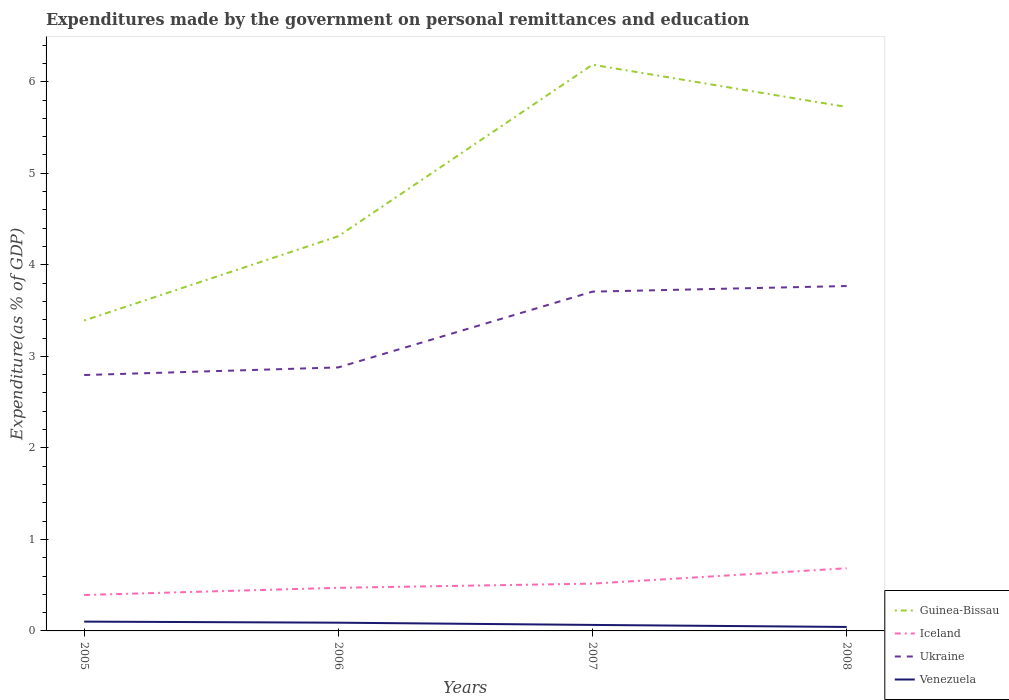How many different coloured lines are there?
Your answer should be very brief. 4. Does the line corresponding to Guinea-Bissau intersect with the line corresponding to Ukraine?
Offer a terse response. No. Across all years, what is the maximum expenditures made by the government on personal remittances and education in Guinea-Bissau?
Offer a terse response. 3.39. In which year was the expenditures made by the government on personal remittances and education in Iceland maximum?
Your response must be concise. 2005. What is the total expenditures made by the government on personal remittances and education in Ukraine in the graph?
Provide a succinct answer. -0.83. What is the difference between the highest and the second highest expenditures made by the government on personal remittances and education in Ukraine?
Your answer should be compact. 0.97. What is the difference between the highest and the lowest expenditures made by the government on personal remittances and education in Guinea-Bissau?
Give a very brief answer. 2. Is the expenditures made by the government on personal remittances and education in Iceland strictly greater than the expenditures made by the government on personal remittances and education in Ukraine over the years?
Your answer should be very brief. Yes. Does the graph contain grids?
Give a very brief answer. No. Where does the legend appear in the graph?
Offer a very short reply. Bottom right. How are the legend labels stacked?
Give a very brief answer. Vertical. What is the title of the graph?
Provide a short and direct response. Expenditures made by the government on personal remittances and education. Does "Channel Islands" appear as one of the legend labels in the graph?
Make the answer very short. No. What is the label or title of the Y-axis?
Keep it short and to the point. Expenditure(as % of GDP). What is the Expenditure(as % of GDP) in Guinea-Bissau in 2005?
Provide a short and direct response. 3.39. What is the Expenditure(as % of GDP) in Iceland in 2005?
Ensure brevity in your answer.  0.39. What is the Expenditure(as % of GDP) of Ukraine in 2005?
Give a very brief answer. 2.8. What is the Expenditure(as % of GDP) in Venezuela in 2005?
Offer a terse response. 0.1. What is the Expenditure(as % of GDP) in Guinea-Bissau in 2006?
Provide a succinct answer. 4.31. What is the Expenditure(as % of GDP) in Iceland in 2006?
Your response must be concise. 0.47. What is the Expenditure(as % of GDP) in Ukraine in 2006?
Make the answer very short. 2.88. What is the Expenditure(as % of GDP) of Venezuela in 2006?
Offer a very short reply. 0.09. What is the Expenditure(as % of GDP) of Guinea-Bissau in 2007?
Give a very brief answer. 6.19. What is the Expenditure(as % of GDP) of Iceland in 2007?
Offer a terse response. 0.52. What is the Expenditure(as % of GDP) of Ukraine in 2007?
Provide a succinct answer. 3.71. What is the Expenditure(as % of GDP) in Venezuela in 2007?
Offer a very short reply. 0.07. What is the Expenditure(as % of GDP) of Guinea-Bissau in 2008?
Offer a very short reply. 5.72. What is the Expenditure(as % of GDP) in Iceland in 2008?
Give a very brief answer. 0.68. What is the Expenditure(as % of GDP) in Ukraine in 2008?
Your response must be concise. 3.77. What is the Expenditure(as % of GDP) of Venezuela in 2008?
Offer a very short reply. 0.04. Across all years, what is the maximum Expenditure(as % of GDP) in Guinea-Bissau?
Your answer should be compact. 6.19. Across all years, what is the maximum Expenditure(as % of GDP) of Iceland?
Offer a very short reply. 0.68. Across all years, what is the maximum Expenditure(as % of GDP) of Ukraine?
Offer a terse response. 3.77. Across all years, what is the maximum Expenditure(as % of GDP) in Venezuela?
Your response must be concise. 0.1. Across all years, what is the minimum Expenditure(as % of GDP) of Guinea-Bissau?
Your answer should be compact. 3.39. Across all years, what is the minimum Expenditure(as % of GDP) in Iceland?
Ensure brevity in your answer.  0.39. Across all years, what is the minimum Expenditure(as % of GDP) in Ukraine?
Your answer should be compact. 2.8. Across all years, what is the minimum Expenditure(as % of GDP) of Venezuela?
Your answer should be very brief. 0.04. What is the total Expenditure(as % of GDP) in Guinea-Bissau in the graph?
Offer a very short reply. 19.61. What is the total Expenditure(as % of GDP) in Iceland in the graph?
Give a very brief answer. 2.06. What is the total Expenditure(as % of GDP) in Ukraine in the graph?
Your response must be concise. 13.15. What is the total Expenditure(as % of GDP) in Venezuela in the graph?
Make the answer very short. 0.3. What is the difference between the Expenditure(as % of GDP) in Guinea-Bissau in 2005 and that in 2006?
Your response must be concise. -0.92. What is the difference between the Expenditure(as % of GDP) in Iceland in 2005 and that in 2006?
Keep it short and to the point. -0.08. What is the difference between the Expenditure(as % of GDP) of Ukraine in 2005 and that in 2006?
Your answer should be compact. -0.08. What is the difference between the Expenditure(as % of GDP) in Venezuela in 2005 and that in 2006?
Your response must be concise. 0.01. What is the difference between the Expenditure(as % of GDP) of Guinea-Bissau in 2005 and that in 2007?
Make the answer very short. -2.79. What is the difference between the Expenditure(as % of GDP) in Iceland in 2005 and that in 2007?
Keep it short and to the point. -0.12. What is the difference between the Expenditure(as % of GDP) of Ukraine in 2005 and that in 2007?
Give a very brief answer. -0.91. What is the difference between the Expenditure(as % of GDP) in Venezuela in 2005 and that in 2007?
Ensure brevity in your answer.  0.04. What is the difference between the Expenditure(as % of GDP) in Guinea-Bissau in 2005 and that in 2008?
Make the answer very short. -2.33. What is the difference between the Expenditure(as % of GDP) in Iceland in 2005 and that in 2008?
Make the answer very short. -0.29. What is the difference between the Expenditure(as % of GDP) of Ukraine in 2005 and that in 2008?
Keep it short and to the point. -0.97. What is the difference between the Expenditure(as % of GDP) of Venezuela in 2005 and that in 2008?
Offer a terse response. 0.06. What is the difference between the Expenditure(as % of GDP) in Guinea-Bissau in 2006 and that in 2007?
Provide a short and direct response. -1.87. What is the difference between the Expenditure(as % of GDP) in Iceland in 2006 and that in 2007?
Ensure brevity in your answer.  -0.05. What is the difference between the Expenditure(as % of GDP) in Ukraine in 2006 and that in 2007?
Ensure brevity in your answer.  -0.83. What is the difference between the Expenditure(as % of GDP) of Venezuela in 2006 and that in 2007?
Offer a very short reply. 0.02. What is the difference between the Expenditure(as % of GDP) in Guinea-Bissau in 2006 and that in 2008?
Provide a succinct answer. -1.41. What is the difference between the Expenditure(as % of GDP) of Iceland in 2006 and that in 2008?
Ensure brevity in your answer.  -0.21. What is the difference between the Expenditure(as % of GDP) of Ukraine in 2006 and that in 2008?
Your response must be concise. -0.89. What is the difference between the Expenditure(as % of GDP) in Venezuela in 2006 and that in 2008?
Provide a succinct answer. 0.05. What is the difference between the Expenditure(as % of GDP) of Guinea-Bissau in 2007 and that in 2008?
Your answer should be very brief. 0.46. What is the difference between the Expenditure(as % of GDP) in Iceland in 2007 and that in 2008?
Offer a terse response. -0.17. What is the difference between the Expenditure(as % of GDP) of Ukraine in 2007 and that in 2008?
Keep it short and to the point. -0.06. What is the difference between the Expenditure(as % of GDP) of Venezuela in 2007 and that in 2008?
Your answer should be very brief. 0.02. What is the difference between the Expenditure(as % of GDP) in Guinea-Bissau in 2005 and the Expenditure(as % of GDP) in Iceland in 2006?
Make the answer very short. 2.92. What is the difference between the Expenditure(as % of GDP) in Guinea-Bissau in 2005 and the Expenditure(as % of GDP) in Ukraine in 2006?
Provide a succinct answer. 0.51. What is the difference between the Expenditure(as % of GDP) of Guinea-Bissau in 2005 and the Expenditure(as % of GDP) of Venezuela in 2006?
Keep it short and to the point. 3.3. What is the difference between the Expenditure(as % of GDP) of Iceland in 2005 and the Expenditure(as % of GDP) of Ukraine in 2006?
Make the answer very short. -2.49. What is the difference between the Expenditure(as % of GDP) of Iceland in 2005 and the Expenditure(as % of GDP) of Venezuela in 2006?
Make the answer very short. 0.3. What is the difference between the Expenditure(as % of GDP) in Ukraine in 2005 and the Expenditure(as % of GDP) in Venezuela in 2006?
Offer a very short reply. 2.71. What is the difference between the Expenditure(as % of GDP) in Guinea-Bissau in 2005 and the Expenditure(as % of GDP) in Iceland in 2007?
Provide a short and direct response. 2.87. What is the difference between the Expenditure(as % of GDP) of Guinea-Bissau in 2005 and the Expenditure(as % of GDP) of Ukraine in 2007?
Provide a succinct answer. -0.32. What is the difference between the Expenditure(as % of GDP) in Guinea-Bissau in 2005 and the Expenditure(as % of GDP) in Venezuela in 2007?
Provide a short and direct response. 3.33. What is the difference between the Expenditure(as % of GDP) of Iceland in 2005 and the Expenditure(as % of GDP) of Ukraine in 2007?
Your response must be concise. -3.31. What is the difference between the Expenditure(as % of GDP) of Iceland in 2005 and the Expenditure(as % of GDP) of Venezuela in 2007?
Your answer should be very brief. 0.33. What is the difference between the Expenditure(as % of GDP) in Ukraine in 2005 and the Expenditure(as % of GDP) in Venezuela in 2007?
Make the answer very short. 2.73. What is the difference between the Expenditure(as % of GDP) of Guinea-Bissau in 2005 and the Expenditure(as % of GDP) of Iceland in 2008?
Your answer should be very brief. 2.71. What is the difference between the Expenditure(as % of GDP) in Guinea-Bissau in 2005 and the Expenditure(as % of GDP) in Ukraine in 2008?
Offer a very short reply. -0.38. What is the difference between the Expenditure(as % of GDP) of Guinea-Bissau in 2005 and the Expenditure(as % of GDP) of Venezuela in 2008?
Provide a short and direct response. 3.35. What is the difference between the Expenditure(as % of GDP) of Iceland in 2005 and the Expenditure(as % of GDP) of Ukraine in 2008?
Your answer should be compact. -3.38. What is the difference between the Expenditure(as % of GDP) of Iceland in 2005 and the Expenditure(as % of GDP) of Venezuela in 2008?
Provide a succinct answer. 0.35. What is the difference between the Expenditure(as % of GDP) in Ukraine in 2005 and the Expenditure(as % of GDP) in Venezuela in 2008?
Give a very brief answer. 2.75. What is the difference between the Expenditure(as % of GDP) of Guinea-Bissau in 2006 and the Expenditure(as % of GDP) of Iceland in 2007?
Your answer should be very brief. 3.8. What is the difference between the Expenditure(as % of GDP) in Guinea-Bissau in 2006 and the Expenditure(as % of GDP) in Ukraine in 2007?
Provide a short and direct response. 0.61. What is the difference between the Expenditure(as % of GDP) of Guinea-Bissau in 2006 and the Expenditure(as % of GDP) of Venezuela in 2007?
Give a very brief answer. 4.25. What is the difference between the Expenditure(as % of GDP) in Iceland in 2006 and the Expenditure(as % of GDP) in Ukraine in 2007?
Make the answer very short. -3.24. What is the difference between the Expenditure(as % of GDP) of Iceland in 2006 and the Expenditure(as % of GDP) of Venezuela in 2007?
Provide a succinct answer. 0.41. What is the difference between the Expenditure(as % of GDP) of Ukraine in 2006 and the Expenditure(as % of GDP) of Venezuela in 2007?
Provide a short and direct response. 2.81. What is the difference between the Expenditure(as % of GDP) of Guinea-Bissau in 2006 and the Expenditure(as % of GDP) of Iceland in 2008?
Provide a succinct answer. 3.63. What is the difference between the Expenditure(as % of GDP) in Guinea-Bissau in 2006 and the Expenditure(as % of GDP) in Ukraine in 2008?
Keep it short and to the point. 0.54. What is the difference between the Expenditure(as % of GDP) in Guinea-Bissau in 2006 and the Expenditure(as % of GDP) in Venezuela in 2008?
Offer a terse response. 4.27. What is the difference between the Expenditure(as % of GDP) in Iceland in 2006 and the Expenditure(as % of GDP) in Ukraine in 2008?
Offer a very short reply. -3.3. What is the difference between the Expenditure(as % of GDP) in Iceland in 2006 and the Expenditure(as % of GDP) in Venezuela in 2008?
Offer a terse response. 0.43. What is the difference between the Expenditure(as % of GDP) of Ukraine in 2006 and the Expenditure(as % of GDP) of Venezuela in 2008?
Make the answer very short. 2.84. What is the difference between the Expenditure(as % of GDP) in Guinea-Bissau in 2007 and the Expenditure(as % of GDP) in Iceland in 2008?
Offer a terse response. 5.5. What is the difference between the Expenditure(as % of GDP) of Guinea-Bissau in 2007 and the Expenditure(as % of GDP) of Ukraine in 2008?
Offer a very short reply. 2.42. What is the difference between the Expenditure(as % of GDP) in Guinea-Bissau in 2007 and the Expenditure(as % of GDP) in Venezuela in 2008?
Provide a short and direct response. 6.14. What is the difference between the Expenditure(as % of GDP) in Iceland in 2007 and the Expenditure(as % of GDP) in Ukraine in 2008?
Offer a very short reply. -3.25. What is the difference between the Expenditure(as % of GDP) of Iceland in 2007 and the Expenditure(as % of GDP) of Venezuela in 2008?
Offer a very short reply. 0.47. What is the difference between the Expenditure(as % of GDP) in Ukraine in 2007 and the Expenditure(as % of GDP) in Venezuela in 2008?
Make the answer very short. 3.66. What is the average Expenditure(as % of GDP) of Guinea-Bissau per year?
Keep it short and to the point. 4.9. What is the average Expenditure(as % of GDP) in Iceland per year?
Offer a very short reply. 0.52. What is the average Expenditure(as % of GDP) in Ukraine per year?
Ensure brevity in your answer.  3.29. What is the average Expenditure(as % of GDP) in Venezuela per year?
Provide a short and direct response. 0.08. In the year 2005, what is the difference between the Expenditure(as % of GDP) in Guinea-Bissau and Expenditure(as % of GDP) in Iceland?
Your answer should be compact. 3. In the year 2005, what is the difference between the Expenditure(as % of GDP) of Guinea-Bissau and Expenditure(as % of GDP) of Ukraine?
Your response must be concise. 0.6. In the year 2005, what is the difference between the Expenditure(as % of GDP) of Guinea-Bissau and Expenditure(as % of GDP) of Venezuela?
Provide a succinct answer. 3.29. In the year 2005, what is the difference between the Expenditure(as % of GDP) of Iceland and Expenditure(as % of GDP) of Ukraine?
Provide a short and direct response. -2.4. In the year 2005, what is the difference between the Expenditure(as % of GDP) in Iceland and Expenditure(as % of GDP) in Venezuela?
Keep it short and to the point. 0.29. In the year 2005, what is the difference between the Expenditure(as % of GDP) of Ukraine and Expenditure(as % of GDP) of Venezuela?
Offer a terse response. 2.69. In the year 2006, what is the difference between the Expenditure(as % of GDP) of Guinea-Bissau and Expenditure(as % of GDP) of Iceland?
Ensure brevity in your answer.  3.84. In the year 2006, what is the difference between the Expenditure(as % of GDP) of Guinea-Bissau and Expenditure(as % of GDP) of Ukraine?
Give a very brief answer. 1.43. In the year 2006, what is the difference between the Expenditure(as % of GDP) in Guinea-Bissau and Expenditure(as % of GDP) in Venezuela?
Your answer should be compact. 4.22. In the year 2006, what is the difference between the Expenditure(as % of GDP) in Iceland and Expenditure(as % of GDP) in Ukraine?
Give a very brief answer. -2.41. In the year 2006, what is the difference between the Expenditure(as % of GDP) of Iceland and Expenditure(as % of GDP) of Venezuela?
Give a very brief answer. 0.38. In the year 2006, what is the difference between the Expenditure(as % of GDP) of Ukraine and Expenditure(as % of GDP) of Venezuela?
Your response must be concise. 2.79. In the year 2007, what is the difference between the Expenditure(as % of GDP) of Guinea-Bissau and Expenditure(as % of GDP) of Iceland?
Give a very brief answer. 5.67. In the year 2007, what is the difference between the Expenditure(as % of GDP) of Guinea-Bissau and Expenditure(as % of GDP) of Ukraine?
Offer a very short reply. 2.48. In the year 2007, what is the difference between the Expenditure(as % of GDP) of Guinea-Bissau and Expenditure(as % of GDP) of Venezuela?
Your answer should be very brief. 6.12. In the year 2007, what is the difference between the Expenditure(as % of GDP) in Iceland and Expenditure(as % of GDP) in Ukraine?
Keep it short and to the point. -3.19. In the year 2007, what is the difference between the Expenditure(as % of GDP) of Iceland and Expenditure(as % of GDP) of Venezuela?
Provide a short and direct response. 0.45. In the year 2007, what is the difference between the Expenditure(as % of GDP) in Ukraine and Expenditure(as % of GDP) in Venezuela?
Offer a very short reply. 3.64. In the year 2008, what is the difference between the Expenditure(as % of GDP) of Guinea-Bissau and Expenditure(as % of GDP) of Iceland?
Keep it short and to the point. 5.04. In the year 2008, what is the difference between the Expenditure(as % of GDP) of Guinea-Bissau and Expenditure(as % of GDP) of Ukraine?
Provide a short and direct response. 1.96. In the year 2008, what is the difference between the Expenditure(as % of GDP) of Guinea-Bissau and Expenditure(as % of GDP) of Venezuela?
Ensure brevity in your answer.  5.68. In the year 2008, what is the difference between the Expenditure(as % of GDP) of Iceland and Expenditure(as % of GDP) of Ukraine?
Offer a very short reply. -3.08. In the year 2008, what is the difference between the Expenditure(as % of GDP) of Iceland and Expenditure(as % of GDP) of Venezuela?
Offer a terse response. 0.64. In the year 2008, what is the difference between the Expenditure(as % of GDP) in Ukraine and Expenditure(as % of GDP) in Venezuela?
Your answer should be compact. 3.72. What is the ratio of the Expenditure(as % of GDP) of Guinea-Bissau in 2005 to that in 2006?
Provide a succinct answer. 0.79. What is the ratio of the Expenditure(as % of GDP) of Iceland in 2005 to that in 2006?
Make the answer very short. 0.83. What is the ratio of the Expenditure(as % of GDP) of Ukraine in 2005 to that in 2006?
Offer a terse response. 0.97. What is the ratio of the Expenditure(as % of GDP) of Venezuela in 2005 to that in 2006?
Provide a short and direct response. 1.13. What is the ratio of the Expenditure(as % of GDP) of Guinea-Bissau in 2005 to that in 2007?
Offer a very short reply. 0.55. What is the ratio of the Expenditure(as % of GDP) of Iceland in 2005 to that in 2007?
Your response must be concise. 0.76. What is the ratio of the Expenditure(as % of GDP) in Ukraine in 2005 to that in 2007?
Ensure brevity in your answer.  0.75. What is the ratio of the Expenditure(as % of GDP) of Venezuela in 2005 to that in 2007?
Your answer should be very brief. 1.55. What is the ratio of the Expenditure(as % of GDP) of Guinea-Bissau in 2005 to that in 2008?
Provide a short and direct response. 0.59. What is the ratio of the Expenditure(as % of GDP) of Iceland in 2005 to that in 2008?
Provide a succinct answer. 0.57. What is the ratio of the Expenditure(as % of GDP) in Ukraine in 2005 to that in 2008?
Make the answer very short. 0.74. What is the ratio of the Expenditure(as % of GDP) in Venezuela in 2005 to that in 2008?
Your response must be concise. 2.34. What is the ratio of the Expenditure(as % of GDP) of Guinea-Bissau in 2006 to that in 2007?
Offer a terse response. 0.7. What is the ratio of the Expenditure(as % of GDP) in Iceland in 2006 to that in 2007?
Provide a succinct answer. 0.91. What is the ratio of the Expenditure(as % of GDP) of Ukraine in 2006 to that in 2007?
Your response must be concise. 0.78. What is the ratio of the Expenditure(as % of GDP) of Venezuela in 2006 to that in 2007?
Offer a terse response. 1.37. What is the ratio of the Expenditure(as % of GDP) of Guinea-Bissau in 2006 to that in 2008?
Your response must be concise. 0.75. What is the ratio of the Expenditure(as % of GDP) in Iceland in 2006 to that in 2008?
Your answer should be compact. 0.69. What is the ratio of the Expenditure(as % of GDP) in Ukraine in 2006 to that in 2008?
Provide a succinct answer. 0.76. What is the ratio of the Expenditure(as % of GDP) of Venezuela in 2006 to that in 2008?
Your response must be concise. 2.07. What is the ratio of the Expenditure(as % of GDP) of Guinea-Bissau in 2007 to that in 2008?
Make the answer very short. 1.08. What is the ratio of the Expenditure(as % of GDP) in Iceland in 2007 to that in 2008?
Make the answer very short. 0.75. What is the ratio of the Expenditure(as % of GDP) of Ukraine in 2007 to that in 2008?
Ensure brevity in your answer.  0.98. What is the ratio of the Expenditure(as % of GDP) of Venezuela in 2007 to that in 2008?
Your answer should be compact. 1.51. What is the difference between the highest and the second highest Expenditure(as % of GDP) in Guinea-Bissau?
Your answer should be compact. 0.46. What is the difference between the highest and the second highest Expenditure(as % of GDP) of Iceland?
Provide a short and direct response. 0.17. What is the difference between the highest and the second highest Expenditure(as % of GDP) in Ukraine?
Provide a succinct answer. 0.06. What is the difference between the highest and the second highest Expenditure(as % of GDP) of Venezuela?
Give a very brief answer. 0.01. What is the difference between the highest and the lowest Expenditure(as % of GDP) in Guinea-Bissau?
Provide a short and direct response. 2.79. What is the difference between the highest and the lowest Expenditure(as % of GDP) in Iceland?
Your response must be concise. 0.29. What is the difference between the highest and the lowest Expenditure(as % of GDP) of Ukraine?
Make the answer very short. 0.97. What is the difference between the highest and the lowest Expenditure(as % of GDP) in Venezuela?
Offer a very short reply. 0.06. 